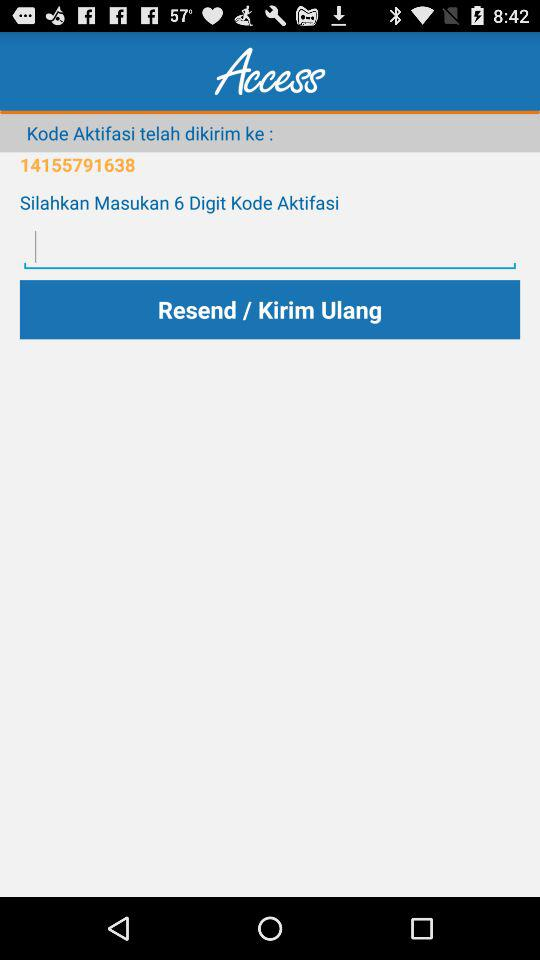How many digits are there in the activation code?
Answer the question using a single word or phrase. 6 